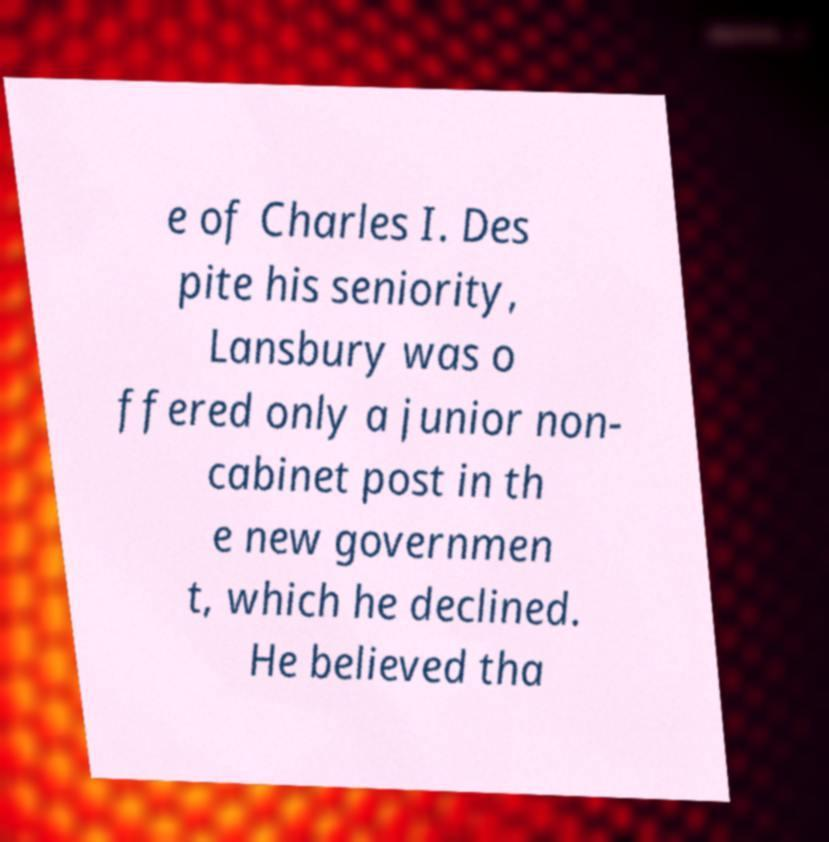Please identify and transcribe the text found in this image. e of Charles I. Des pite his seniority, Lansbury was o ffered only a junior non- cabinet post in th e new governmen t, which he declined. He believed tha 